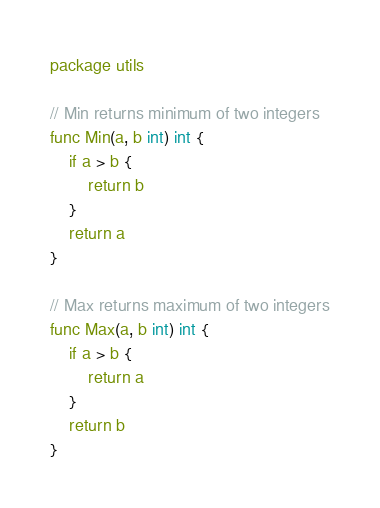<code> <loc_0><loc_0><loc_500><loc_500><_Go_>package utils

// Min returns minimum of two integers
func Min(a, b int) int {
	if a > b {
		return b
	}
	return a
}

// Max returns maximum of two integers
func Max(a, b int) int {
	if a > b {
		return a
	}
	return b
}
</code> 